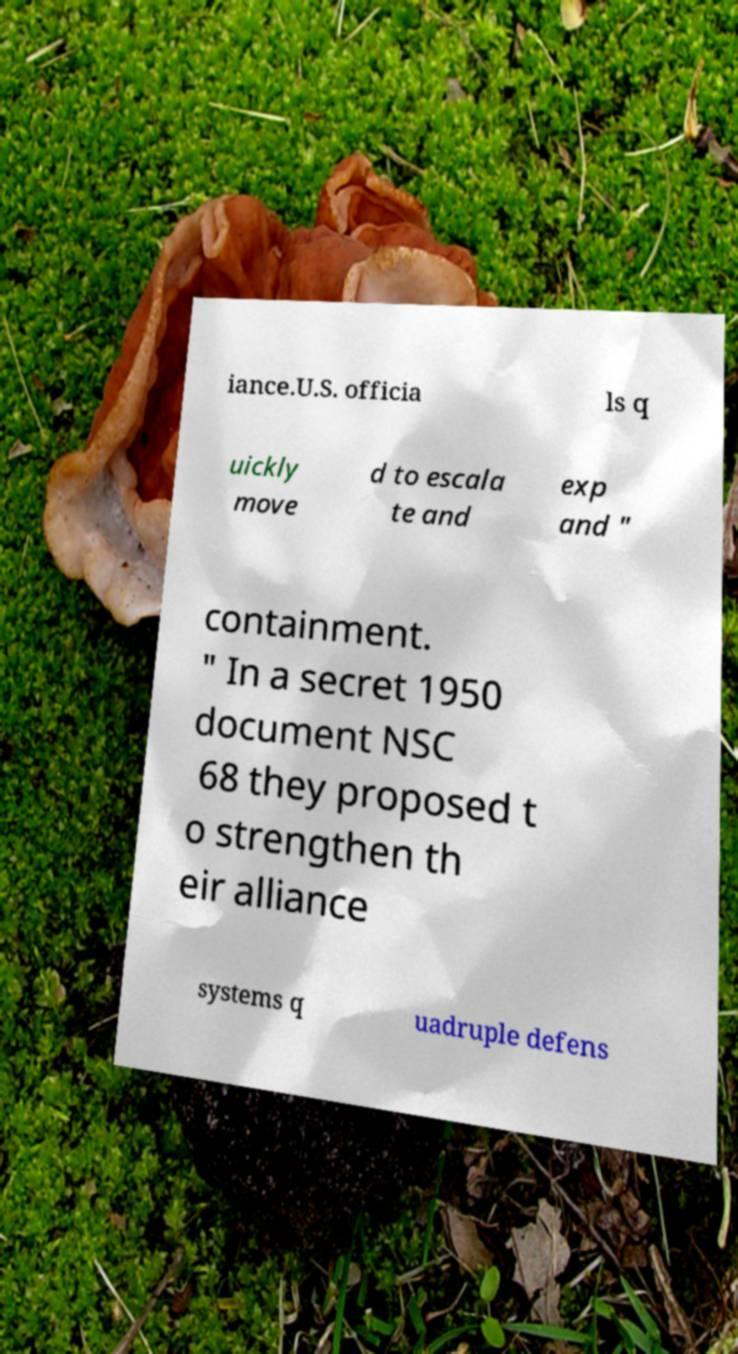Please identify and transcribe the text found in this image. iance.U.S. officia ls q uickly move d to escala te and exp and " containment. " In a secret 1950 document NSC 68 they proposed t o strengthen th eir alliance systems q uadruple defens 